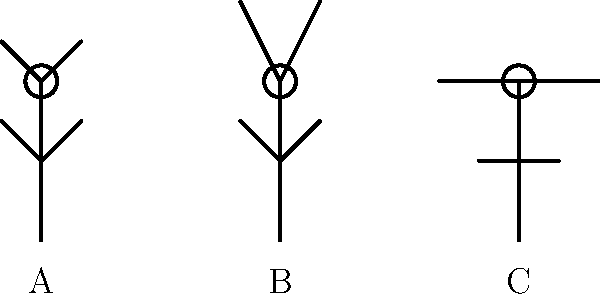As a pastor inspired by Billy Graham's sermons, you often observe various prayer postures during worship services. In the image above, which figure represents the most common prayer position in many Christian traditions, often referred to as the "orans" position? To answer this question, let's analyze each figure in the image:

1. Figure A: This figure has its arms raised upward and slightly outward, with palms facing upward. This position is known as the "orans" position, which is Latin for "praying" or "pleading." It's a ancient and widely recognized prayer posture in Christianity.

2. Figure B: This figure has its arms raised straight up above its head. While this can be a posture of praise or surrender, it's not typically associated with the traditional prayer position.

3. Figure C: This figure has its arms outstretched to the sides, parallel to the ground. This posture is sometimes seen in worship, particularly in more charismatic services, but it's not the most common prayer position.

The "orans" position, represented by Figure A, is the most common and traditional prayer posture in many Christian denominations. It symbolizes openness to God, receptivity, and an offering of oneself in prayer. This posture has been depicted in Christian art for centuries and is still widely used in liturgical settings and personal prayer.
Answer: A 